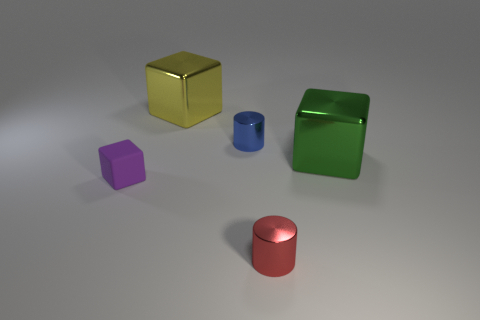There is a green shiny object; are there any red objects behind it?
Your answer should be very brief. No. There is a green metallic thing; is its shape the same as the large thing behind the large green metallic thing?
Keep it short and to the point. Yes. What number of things are either big metallic cubes left of the blue cylinder or large shiny things?
Keep it short and to the point. 2. Is there any other thing that has the same material as the tiny blue thing?
Keep it short and to the point. Yes. How many objects are both behind the tiny blue metallic object and in front of the rubber cube?
Offer a terse response. 0. How many things are either objects that are behind the blue cylinder or small objects in front of the tiny purple matte thing?
Provide a short and direct response. 2. How many other things are the same shape as the big yellow object?
Offer a terse response. 2. There is a block that is behind the small blue metallic thing; is it the same color as the tiny rubber block?
Provide a short and direct response. No. What number of other things are the same size as the blue metallic cylinder?
Your answer should be compact. 2. Does the purple object have the same material as the green object?
Make the answer very short. No. 